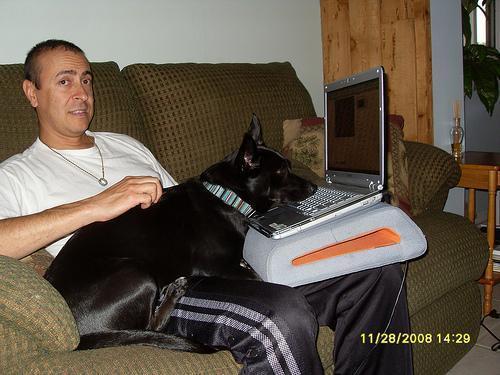How many white dogs are there?
Give a very brief answer. 0. 